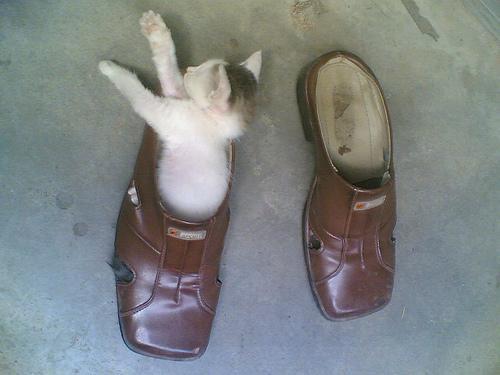How many people are in the room?
Give a very brief answer. 0. 